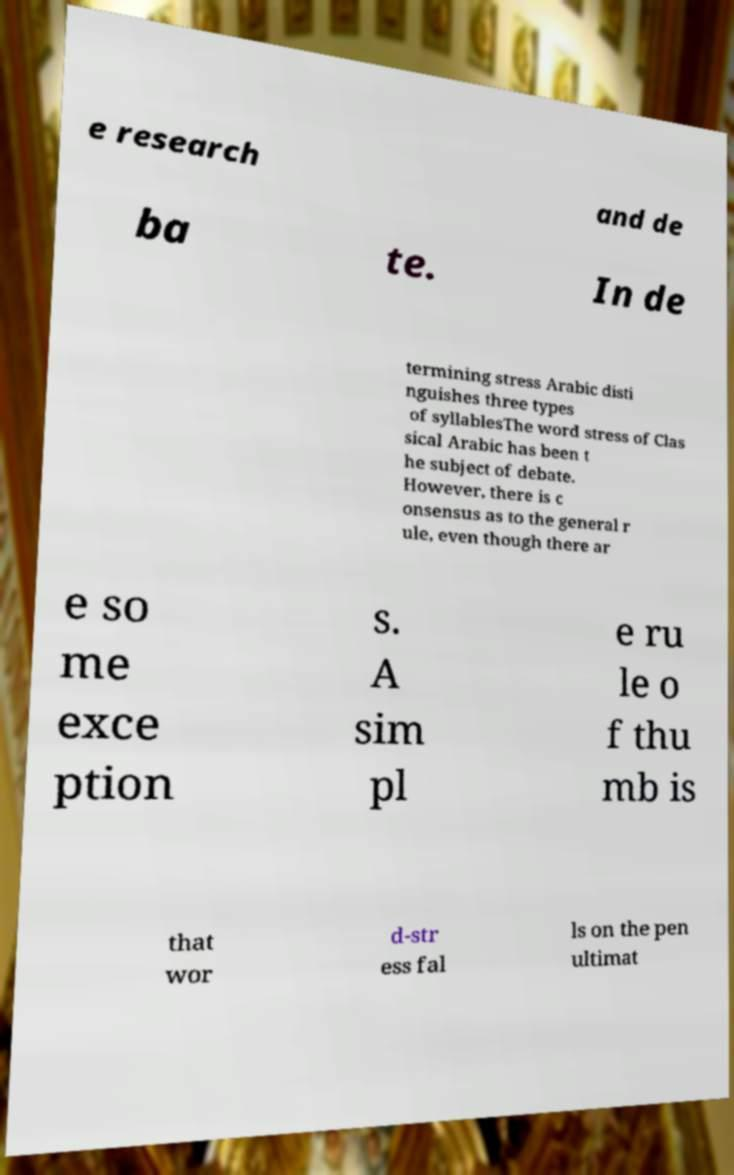What messages or text are displayed in this image? I need them in a readable, typed format. e research and de ba te. In de termining stress Arabic disti nguishes three types of syllablesThe word stress of Clas sical Arabic has been t he subject of debate. However, there is c onsensus as to the general r ule, even though there ar e so me exce ption s. A sim pl e ru le o f thu mb is that wor d-str ess fal ls on the pen ultimat 